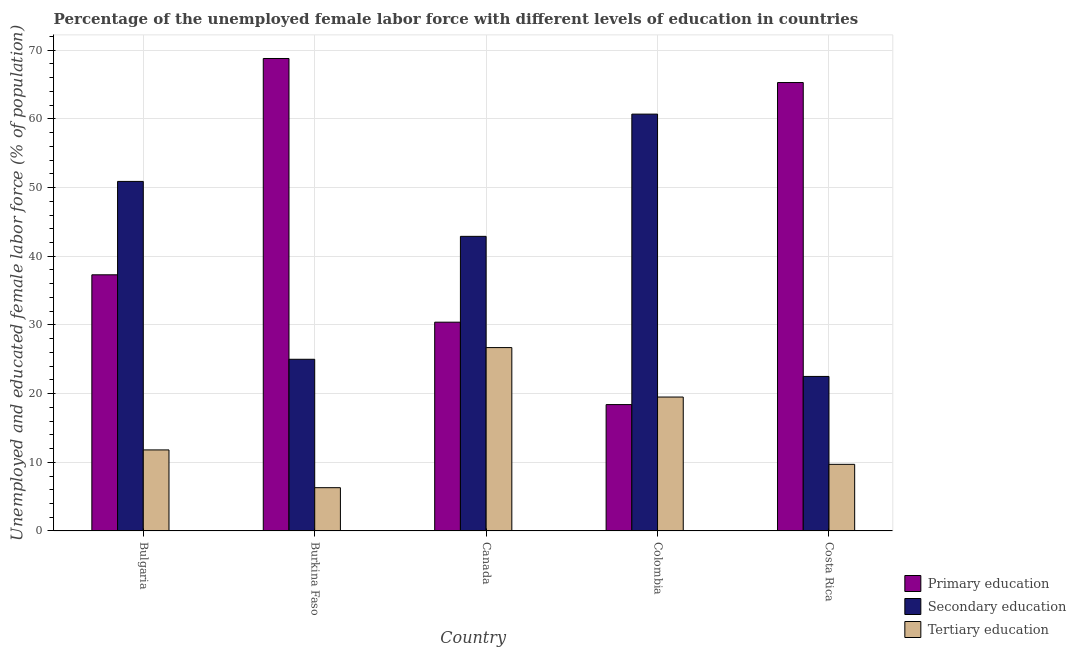How many different coloured bars are there?
Provide a short and direct response. 3. Are the number of bars per tick equal to the number of legend labels?
Give a very brief answer. Yes. How many bars are there on the 3rd tick from the left?
Provide a short and direct response. 3. How many bars are there on the 1st tick from the right?
Provide a succinct answer. 3. What is the label of the 4th group of bars from the left?
Give a very brief answer. Colombia. In how many cases, is the number of bars for a given country not equal to the number of legend labels?
Keep it short and to the point. 0. What is the percentage of female labor force who received primary education in Burkina Faso?
Your answer should be compact. 68.8. Across all countries, what is the maximum percentage of female labor force who received secondary education?
Keep it short and to the point. 60.7. Across all countries, what is the minimum percentage of female labor force who received primary education?
Make the answer very short. 18.4. In which country was the percentage of female labor force who received primary education maximum?
Offer a terse response. Burkina Faso. What is the total percentage of female labor force who received secondary education in the graph?
Keep it short and to the point. 202. What is the difference between the percentage of female labor force who received tertiary education in Bulgaria and that in Costa Rica?
Ensure brevity in your answer.  2.1. What is the difference between the percentage of female labor force who received secondary education in Canada and the percentage of female labor force who received tertiary education in Costa Rica?
Your answer should be very brief. 33.2. What is the average percentage of female labor force who received secondary education per country?
Offer a very short reply. 40.4. What is the difference between the percentage of female labor force who received tertiary education and percentage of female labor force who received primary education in Bulgaria?
Ensure brevity in your answer.  -25.5. In how many countries, is the percentage of female labor force who received primary education greater than 2 %?
Make the answer very short. 5. What is the ratio of the percentage of female labor force who received tertiary education in Bulgaria to that in Costa Rica?
Offer a very short reply. 1.22. What is the difference between the highest and the lowest percentage of female labor force who received secondary education?
Your answer should be compact. 38.2. Is the sum of the percentage of female labor force who received secondary education in Bulgaria and Costa Rica greater than the maximum percentage of female labor force who received primary education across all countries?
Keep it short and to the point. Yes. What does the 2nd bar from the left in Canada represents?
Keep it short and to the point. Secondary education. What does the 3rd bar from the right in Canada represents?
Offer a terse response. Primary education. How many bars are there?
Your response must be concise. 15. Are all the bars in the graph horizontal?
Your response must be concise. No. How many countries are there in the graph?
Provide a succinct answer. 5. What is the difference between two consecutive major ticks on the Y-axis?
Ensure brevity in your answer.  10. Are the values on the major ticks of Y-axis written in scientific E-notation?
Provide a succinct answer. No. Where does the legend appear in the graph?
Your answer should be very brief. Bottom right. How many legend labels are there?
Make the answer very short. 3. How are the legend labels stacked?
Your response must be concise. Vertical. What is the title of the graph?
Provide a short and direct response. Percentage of the unemployed female labor force with different levels of education in countries. Does "Gaseous fuel" appear as one of the legend labels in the graph?
Give a very brief answer. No. What is the label or title of the X-axis?
Provide a short and direct response. Country. What is the label or title of the Y-axis?
Offer a terse response. Unemployed and educated female labor force (% of population). What is the Unemployed and educated female labor force (% of population) of Primary education in Bulgaria?
Provide a short and direct response. 37.3. What is the Unemployed and educated female labor force (% of population) of Secondary education in Bulgaria?
Offer a very short reply. 50.9. What is the Unemployed and educated female labor force (% of population) of Tertiary education in Bulgaria?
Keep it short and to the point. 11.8. What is the Unemployed and educated female labor force (% of population) of Primary education in Burkina Faso?
Your answer should be very brief. 68.8. What is the Unemployed and educated female labor force (% of population) in Secondary education in Burkina Faso?
Offer a terse response. 25. What is the Unemployed and educated female labor force (% of population) in Tertiary education in Burkina Faso?
Offer a terse response. 6.3. What is the Unemployed and educated female labor force (% of population) in Primary education in Canada?
Give a very brief answer. 30.4. What is the Unemployed and educated female labor force (% of population) of Secondary education in Canada?
Give a very brief answer. 42.9. What is the Unemployed and educated female labor force (% of population) in Tertiary education in Canada?
Provide a succinct answer. 26.7. What is the Unemployed and educated female labor force (% of population) in Primary education in Colombia?
Provide a succinct answer. 18.4. What is the Unemployed and educated female labor force (% of population) in Secondary education in Colombia?
Your answer should be very brief. 60.7. What is the Unemployed and educated female labor force (% of population) in Primary education in Costa Rica?
Your response must be concise. 65.3. What is the Unemployed and educated female labor force (% of population) in Secondary education in Costa Rica?
Ensure brevity in your answer.  22.5. What is the Unemployed and educated female labor force (% of population) of Tertiary education in Costa Rica?
Keep it short and to the point. 9.7. Across all countries, what is the maximum Unemployed and educated female labor force (% of population) in Primary education?
Provide a short and direct response. 68.8. Across all countries, what is the maximum Unemployed and educated female labor force (% of population) in Secondary education?
Provide a succinct answer. 60.7. Across all countries, what is the maximum Unemployed and educated female labor force (% of population) of Tertiary education?
Your response must be concise. 26.7. Across all countries, what is the minimum Unemployed and educated female labor force (% of population) in Primary education?
Ensure brevity in your answer.  18.4. Across all countries, what is the minimum Unemployed and educated female labor force (% of population) in Tertiary education?
Make the answer very short. 6.3. What is the total Unemployed and educated female labor force (% of population) in Primary education in the graph?
Your answer should be very brief. 220.2. What is the total Unemployed and educated female labor force (% of population) of Secondary education in the graph?
Provide a short and direct response. 202. What is the total Unemployed and educated female labor force (% of population) of Tertiary education in the graph?
Keep it short and to the point. 74. What is the difference between the Unemployed and educated female labor force (% of population) in Primary education in Bulgaria and that in Burkina Faso?
Your response must be concise. -31.5. What is the difference between the Unemployed and educated female labor force (% of population) in Secondary education in Bulgaria and that in Burkina Faso?
Your answer should be very brief. 25.9. What is the difference between the Unemployed and educated female labor force (% of population) of Tertiary education in Bulgaria and that in Burkina Faso?
Offer a very short reply. 5.5. What is the difference between the Unemployed and educated female labor force (% of population) in Tertiary education in Bulgaria and that in Canada?
Offer a terse response. -14.9. What is the difference between the Unemployed and educated female labor force (% of population) of Tertiary education in Bulgaria and that in Colombia?
Provide a short and direct response. -7.7. What is the difference between the Unemployed and educated female labor force (% of population) of Primary education in Bulgaria and that in Costa Rica?
Offer a very short reply. -28. What is the difference between the Unemployed and educated female labor force (% of population) in Secondary education in Bulgaria and that in Costa Rica?
Keep it short and to the point. 28.4. What is the difference between the Unemployed and educated female labor force (% of population) in Tertiary education in Bulgaria and that in Costa Rica?
Keep it short and to the point. 2.1. What is the difference between the Unemployed and educated female labor force (% of population) in Primary education in Burkina Faso and that in Canada?
Provide a short and direct response. 38.4. What is the difference between the Unemployed and educated female labor force (% of population) of Secondary education in Burkina Faso and that in Canada?
Provide a short and direct response. -17.9. What is the difference between the Unemployed and educated female labor force (% of population) of Tertiary education in Burkina Faso and that in Canada?
Your answer should be very brief. -20.4. What is the difference between the Unemployed and educated female labor force (% of population) of Primary education in Burkina Faso and that in Colombia?
Provide a succinct answer. 50.4. What is the difference between the Unemployed and educated female labor force (% of population) in Secondary education in Burkina Faso and that in Colombia?
Give a very brief answer. -35.7. What is the difference between the Unemployed and educated female labor force (% of population) of Tertiary education in Burkina Faso and that in Colombia?
Ensure brevity in your answer.  -13.2. What is the difference between the Unemployed and educated female labor force (% of population) of Primary education in Burkina Faso and that in Costa Rica?
Your response must be concise. 3.5. What is the difference between the Unemployed and educated female labor force (% of population) of Secondary education in Burkina Faso and that in Costa Rica?
Keep it short and to the point. 2.5. What is the difference between the Unemployed and educated female labor force (% of population) of Tertiary education in Burkina Faso and that in Costa Rica?
Give a very brief answer. -3.4. What is the difference between the Unemployed and educated female labor force (% of population) of Secondary education in Canada and that in Colombia?
Provide a succinct answer. -17.8. What is the difference between the Unemployed and educated female labor force (% of population) of Primary education in Canada and that in Costa Rica?
Offer a very short reply. -34.9. What is the difference between the Unemployed and educated female labor force (% of population) of Secondary education in Canada and that in Costa Rica?
Ensure brevity in your answer.  20.4. What is the difference between the Unemployed and educated female labor force (% of population) in Tertiary education in Canada and that in Costa Rica?
Offer a terse response. 17. What is the difference between the Unemployed and educated female labor force (% of population) in Primary education in Colombia and that in Costa Rica?
Your answer should be compact. -46.9. What is the difference between the Unemployed and educated female labor force (% of population) in Secondary education in Colombia and that in Costa Rica?
Give a very brief answer. 38.2. What is the difference between the Unemployed and educated female labor force (% of population) in Tertiary education in Colombia and that in Costa Rica?
Provide a short and direct response. 9.8. What is the difference between the Unemployed and educated female labor force (% of population) of Primary education in Bulgaria and the Unemployed and educated female labor force (% of population) of Secondary education in Burkina Faso?
Your answer should be compact. 12.3. What is the difference between the Unemployed and educated female labor force (% of population) of Primary education in Bulgaria and the Unemployed and educated female labor force (% of population) of Tertiary education in Burkina Faso?
Your answer should be very brief. 31. What is the difference between the Unemployed and educated female labor force (% of population) in Secondary education in Bulgaria and the Unemployed and educated female labor force (% of population) in Tertiary education in Burkina Faso?
Provide a short and direct response. 44.6. What is the difference between the Unemployed and educated female labor force (% of population) in Primary education in Bulgaria and the Unemployed and educated female labor force (% of population) in Secondary education in Canada?
Provide a short and direct response. -5.6. What is the difference between the Unemployed and educated female labor force (% of population) in Primary education in Bulgaria and the Unemployed and educated female labor force (% of population) in Tertiary education in Canada?
Your answer should be very brief. 10.6. What is the difference between the Unemployed and educated female labor force (% of population) of Secondary education in Bulgaria and the Unemployed and educated female labor force (% of population) of Tertiary education in Canada?
Keep it short and to the point. 24.2. What is the difference between the Unemployed and educated female labor force (% of population) of Primary education in Bulgaria and the Unemployed and educated female labor force (% of population) of Secondary education in Colombia?
Keep it short and to the point. -23.4. What is the difference between the Unemployed and educated female labor force (% of population) in Primary education in Bulgaria and the Unemployed and educated female labor force (% of population) in Tertiary education in Colombia?
Provide a succinct answer. 17.8. What is the difference between the Unemployed and educated female labor force (% of population) in Secondary education in Bulgaria and the Unemployed and educated female labor force (% of population) in Tertiary education in Colombia?
Provide a succinct answer. 31.4. What is the difference between the Unemployed and educated female labor force (% of population) in Primary education in Bulgaria and the Unemployed and educated female labor force (% of population) in Tertiary education in Costa Rica?
Your answer should be compact. 27.6. What is the difference between the Unemployed and educated female labor force (% of population) in Secondary education in Bulgaria and the Unemployed and educated female labor force (% of population) in Tertiary education in Costa Rica?
Provide a succinct answer. 41.2. What is the difference between the Unemployed and educated female labor force (% of population) of Primary education in Burkina Faso and the Unemployed and educated female labor force (% of population) of Secondary education in Canada?
Your answer should be compact. 25.9. What is the difference between the Unemployed and educated female labor force (% of population) in Primary education in Burkina Faso and the Unemployed and educated female labor force (% of population) in Tertiary education in Canada?
Your response must be concise. 42.1. What is the difference between the Unemployed and educated female labor force (% of population) in Primary education in Burkina Faso and the Unemployed and educated female labor force (% of population) in Tertiary education in Colombia?
Your answer should be compact. 49.3. What is the difference between the Unemployed and educated female labor force (% of population) of Primary education in Burkina Faso and the Unemployed and educated female labor force (% of population) of Secondary education in Costa Rica?
Provide a succinct answer. 46.3. What is the difference between the Unemployed and educated female labor force (% of population) in Primary education in Burkina Faso and the Unemployed and educated female labor force (% of population) in Tertiary education in Costa Rica?
Give a very brief answer. 59.1. What is the difference between the Unemployed and educated female labor force (% of population) in Secondary education in Burkina Faso and the Unemployed and educated female labor force (% of population) in Tertiary education in Costa Rica?
Make the answer very short. 15.3. What is the difference between the Unemployed and educated female labor force (% of population) in Primary education in Canada and the Unemployed and educated female labor force (% of population) in Secondary education in Colombia?
Your answer should be very brief. -30.3. What is the difference between the Unemployed and educated female labor force (% of population) of Secondary education in Canada and the Unemployed and educated female labor force (% of population) of Tertiary education in Colombia?
Ensure brevity in your answer.  23.4. What is the difference between the Unemployed and educated female labor force (% of population) of Primary education in Canada and the Unemployed and educated female labor force (% of population) of Tertiary education in Costa Rica?
Make the answer very short. 20.7. What is the difference between the Unemployed and educated female labor force (% of population) of Secondary education in Canada and the Unemployed and educated female labor force (% of population) of Tertiary education in Costa Rica?
Your response must be concise. 33.2. What is the difference between the Unemployed and educated female labor force (% of population) of Primary education in Colombia and the Unemployed and educated female labor force (% of population) of Secondary education in Costa Rica?
Your answer should be compact. -4.1. What is the difference between the Unemployed and educated female labor force (% of population) of Primary education in Colombia and the Unemployed and educated female labor force (% of population) of Tertiary education in Costa Rica?
Ensure brevity in your answer.  8.7. What is the difference between the Unemployed and educated female labor force (% of population) in Secondary education in Colombia and the Unemployed and educated female labor force (% of population) in Tertiary education in Costa Rica?
Provide a succinct answer. 51. What is the average Unemployed and educated female labor force (% of population) of Primary education per country?
Offer a terse response. 44.04. What is the average Unemployed and educated female labor force (% of population) of Secondary education per country?
Provide a short and direct response. 40.4. What is the average Unemployed and educated female labor force (% of population) of Tertiary education per country?
Give a very brief answer. 14.8. What is the difference between the Unemployed and educated female labor force (% of population) of Primary education and Unemployed and educated female labor force (% of population) of Tertiary education in Bulgaria?
Your response must be concise. 25.5. What is the difference between the Unemployed and educated female labor force (% of population) in Secondary education and Unemployed and educated female labor force (% of population) in Tertiary education in Bulgaria?
Your response must be concise. 39.1. What is the difference between the Unemployed and educated female labor force (% of population) in Primary education and Unemployed and educated female labor force (% of population) in Secondary education in Burkina Faso?
Offer a terse response. 43.8. What is the difference between the Unemployed and educated female labor force (% of population) of Primary education and Unemployed and educated female labor force (% of population) of Tertiary education in Burkina Faso?
Keep it short and to the point. 62.5. What is the difference between the Unemployed and educated female labor force (% of population) of Primary education and Unemployed and educated female labor force (% of population) of Tertiary education in Canada?
Provide a short and direct response. 3.7. What is the difference between the Unemployed and educated female labor force (% of population) of Primary education and Unemployed and educated female labor force (% of population) of Secondary education in Colombia?
Keep it short and to the point. -42.3. What is the difference between the Unemployed and educated female labor force (% of population) of Secondary education and Unemployed and educated female labor force (% of population) of Tertiary education in Colombia?
Provide a short and direct response. 41.2. What is the difference between the Unemployed and educated female labor force (% of population) of Primary education and Unemployed and educated female labor force (% of population) of Secondary education in Costa Rica?
Your answer should be very brief. 42.8. What is the difference between the Unemployed and educated female labor force (% of population) of Primary education and Unemployed and educated female labor force (% of population) of Tertiary education in Costa Rica?
Provide a succinct answer. 55.6. What is the difference between the Unemployed and educated female labor force (% of population) of Secondary education and Unemployed and educated female labor force (% of population) of Tertiary education in Costa Rica?
Provide a short and direct response. 12.8. What is the ratio of the Unemployed and educated female labor force (% of population) in Primary education in Bulgaria to that in Burkina Faso?
Give a very brief answer. 0.54. What is the ratio of the Unemployed and educated female labor force (% of population) of Secondary education in Bulgaria to that in Burkina Faso?
Your response must be concise. 2.04. What is the ratio of the Unemployed and educated female labor force (% of population) in Tertiary education in Bulgaria to that in Burkina Faso?
Offer a terse response. 1.87. What is the ratio of the Unemployed and educated female labor force (% of population) in Primary education in Bulgaria to that in Canada?
Your response must be concise. 1.23. What is the ratio of the Unemployed and educated female labor force (% of population) of Secondary education in Bulgaria to that in Canada?
Offer a terse response. 1.19. What is the ratio of the Unemployed and educated female labor force (% of population) of Tertiary education in Bulgaria to that in Canada?
Ensure brevity in your answer.  0.44. What is the ratio of the Unemployed and educated female labor force (% of population) in Primary education in Bulgaria to that in Colombia?
Give a very brief answer. 2.03. What is the ratio of the Unemployed and educated female labor force (% of population) of Secondary education in Bulgaria to that in Colombia?
Your answer should be very brief. 0.84. What is the ratio of the Unemployed and educated female labor force (% of population) in Tertiary education in Bulgaria to that in Colombia?
Ensure brevity in your answer.  0.61. What is the ratio of the Unemployed and educated female labor force (% of population) of Primary education in Bulgaria to that in Costa Rica?
Offer a very short reply. 0.57. What is the ratio of the Unemployed and educated female labor force (% of population) of Secondary education in Bulgaria to that in Costa Rica?
Your answer should be compact. 2.26. What is the ratio of the Unemployed and educated female labor force (% of population) in Tertiary education in Bulgaria to that in Costa Rica?
Ensure brevity in your answer.  1.22. What is the ratio of the Unemployed and educated female labor force (% of population) of Primary education in Burkina Faso to that in Canada?
Make the answer very short. 2.26. What is the ratio of the Unemployed and educated female labor force (% of population) of Secondary education in Burkina Faso to that in Canada?
Your answer should be compact. 0.58. What is the ratio of the Unemployed and educated female labor force (% of population) of Tertiary education in Burkina Faso to that in Canada?
Offer a very short reply. 0.24. What is the ratio of the Unemployed and educated female labor force (% of population) of Primary education in Burkina Faso to that in Colombia?
Give a very brief answer. 3.74. What is the ratio of the Unemployed and educated female labor force (% of population) of Secondary education in Burkina Faso to that in Colombia?
Ensure brevity in your answer.  0.41. What is the ratio of the Unemployed and educated female labor force (% of population) of Tertiary education in Burkina Faso to that in Colombia?
Your answer should be very brief. 0.32. What is the ratio of the Unemployed and educated female labor force (% of population) in Primary education in Burkina Faso to that in Costa Rica?
Give a very brief answer. 1.05. What is the ratio of the Unemployed and educated female labor force (% of population) of Tertiary education in Burkina Faso to that in Costa Rica?
Give a very brief answer. 0.65. What is the ratio of the Unemployed and educated female labor force (% of population) in Primary education in Canada to that in Colombia?
Provide a succinct answer. 1.65. What is the ratio of the Unemployed and educated female labor force (% of population) of Secondary education in Canada to that in Colombia?
Offer a very short reply. 0.71. What is the ratio of the Unemployed and educated female labor force (% of population) of Tertiary education in Canada to that in Colombia?
Your answer should be very brief. 1.37. What is the ratio of the Unemployed and educated female labor force (% of population) in Primary education in Canada to that in Costa Rica?
Keep it short and to the point. 0.47. What is the ratio of the Unemployed and educated female labor force (% of population) of Secondary education in Canada to that in Costa Rica?
Offer a terse response. 1.91. What is the ratio of the Unemployed and educated female labor force (% of population) of Tertiary education in Canada to that in Costa Rica?
Keep it short and to the point. 2.75. What is the ratio of the Unemployed and educated female labor force (% of population) of Primary education in Colombia to that in Costa Rica?
Your answer should be compact. 0.28. What is the ratio of the Unemployed and educated female labor force (% of population) in Secondary education in Colombia to that in Costa Rica?
Provide a short and direct response. 2.7. What is the ratio of the Unemployed and educated female labor force (% of population) in Tertiary education in Colombia to that in Costa Rica?
Offer a terse response. 2.01. What is the difference between the highest and the lowest Unemployed and educated female labor force (% of population) of Primary education?
Your answer should be compact. 50.4. What is the difference between the highest and the lowest Unemployed and educated female labor force (% of population) of Secondary education?
Your response must be concise. 38.2. What is the difference between the highest and the lowest Unemployed and educated female labor force (% of population) of Tertiary education?
Provide a short and direct response. 20.4. 